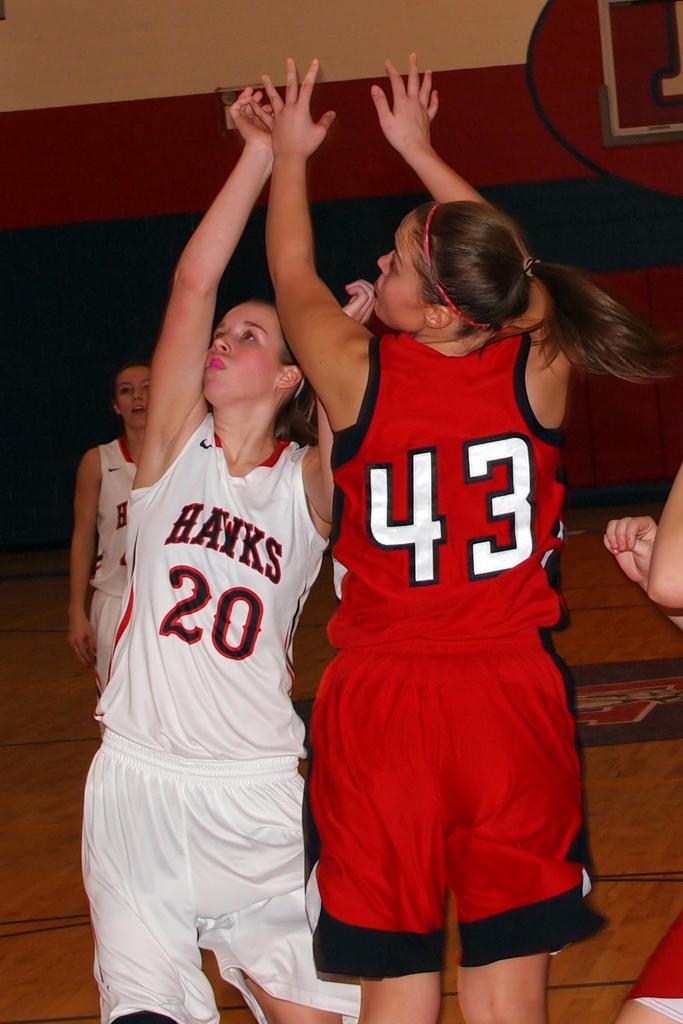Describe this image in one or two sentences. In this image I see 3 girls in which these both are wearing white color jerseys and this girl is wearing red color jersey and I see that there is a word written over here and I see the numbers and I see the path on which there are black lines and I see a person over here. 